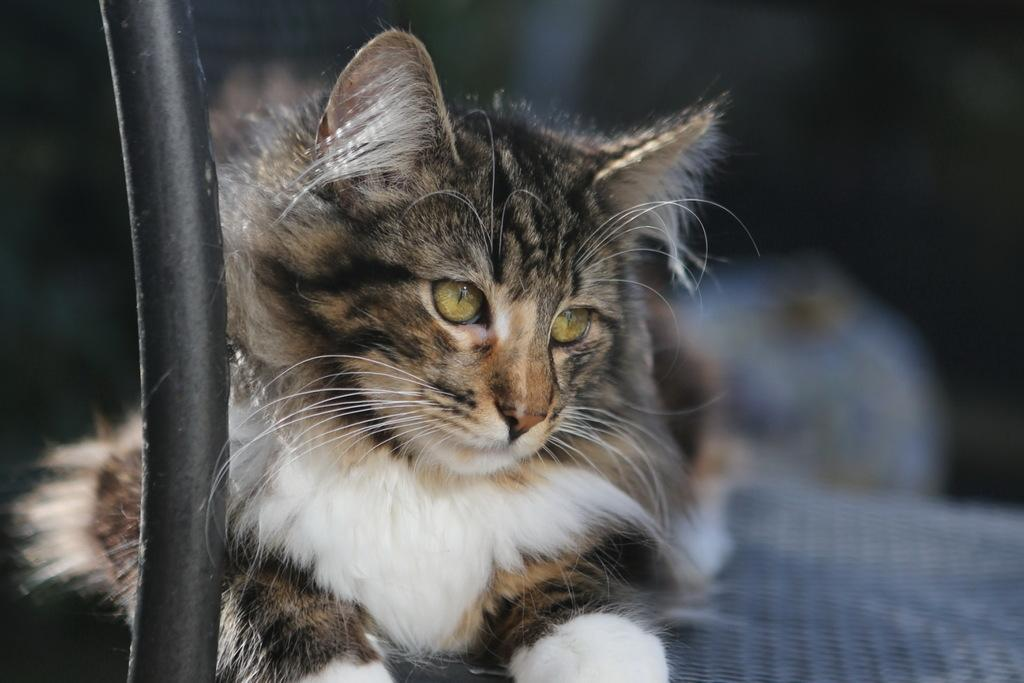What type of animal is in the image? There is a cat in the image. What colors can be seen on the cat? The cat has brown, black, and white colors. What is located in front of the cat? There is a black object in front of the cat. How would you describe the background of the image? The background of the image is blurred. Where is the railway located in the image? There is no railway present in the image. Can you tell me how many animals are in the zoo in the image? There is no zoo present in the image, and only one cat is visible. 